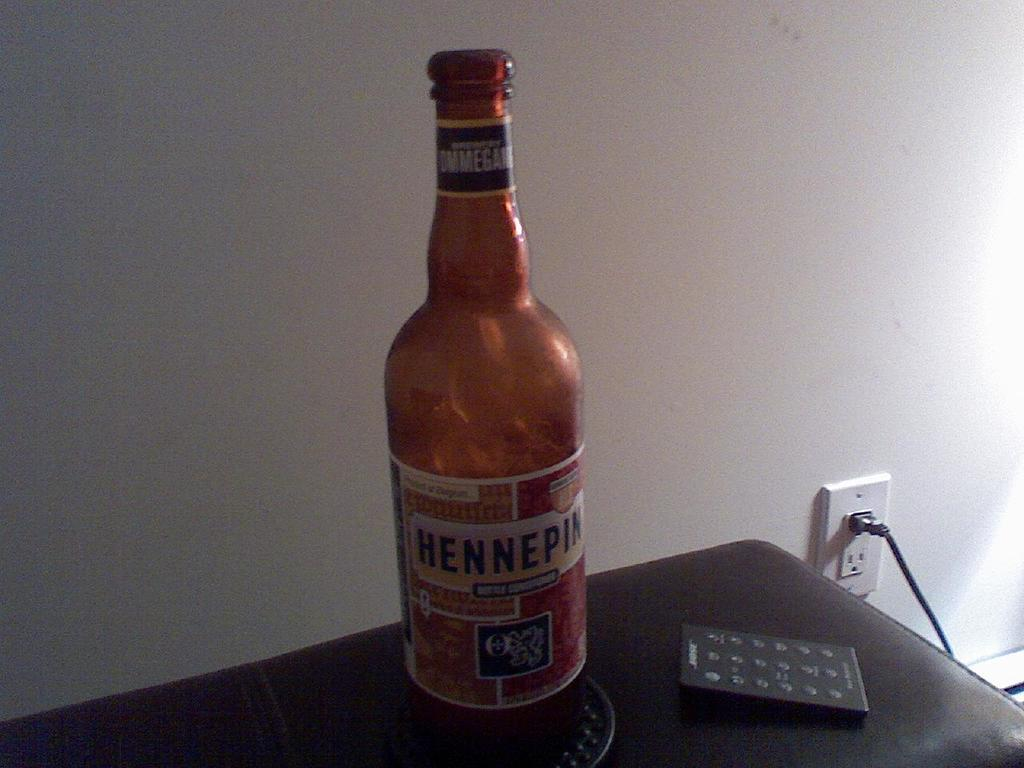<image>
Share a concise interpretation of the image provided. A bottle of Hennepin beer sitting on a desk 